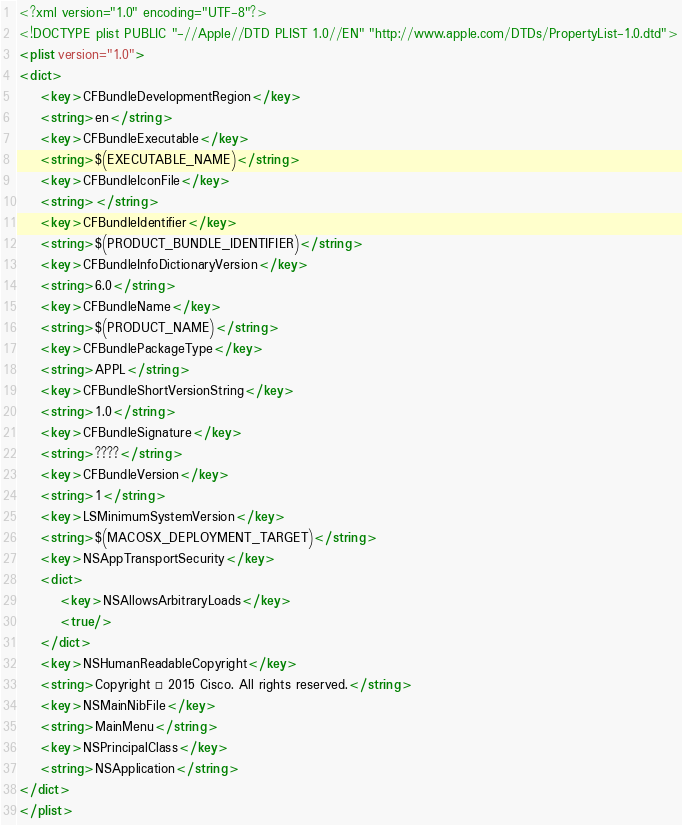<code> <loc_0><loc_0><loc_500><loc_500><_XML_><?xml version="1.0" encoding="UTF-8"?>
<!DOCTYPE plist PUBLIC "-//Apple//DTD PLIST 1.0//EN" "http://www.apple.com/DTDs/PropertyList-1.0.dtd">
<plist version="1.0">
<dict>
	<key>CFBundleDevelopmentRegion</key>
	<string>en</string>
	<key>CFBundleExecutable</key>
	<string>$(EXECUTABLE_NAME)</string>
	<key>CFBundleIconFile</key>
	<string></string>
	<key>CFBundleIdentifier</key>
	<string>$(PRODUCT_BUNDLE_IDENTIFIER)</string>
	<key>CFBundleInfoDictionaryVersion</key>
	<string>6.0</string>
	<key>CFBundleName</key>
	<string>$(PRODUCT_NAME)</string>
	<key>CFBundlePackageType</key>
	<string>APPL</string>
	<key>CFBundleShortVersionString</key>
	<string>1.0</string>
	<key>CFBundleSignature</key>
	<string>????</string>
	<key>CFBundleVersion</key>
	<string>1</string>
	<key>LSMinimumSystemVersion</key>
	<string>$(MACOSX_DEPLOYMENT_TARGET)</string>
	<key>NSAppTransportSecurity</key>
	<dict>
		<key>NSAllowsArbitraryLoads</key>
		<true/>
	</dict>
	<key>NSHumanReadableCopyright</key>
	<string>Copyright © 2015 Cisco. All rights reserved.</string>
	<key>NSMainNibFile</key>
	<string>MainMenu</string>
	<key>NSPrincipalClass</key>
	<string>NSApplication</string>
</dict>
</plist>
</code> 